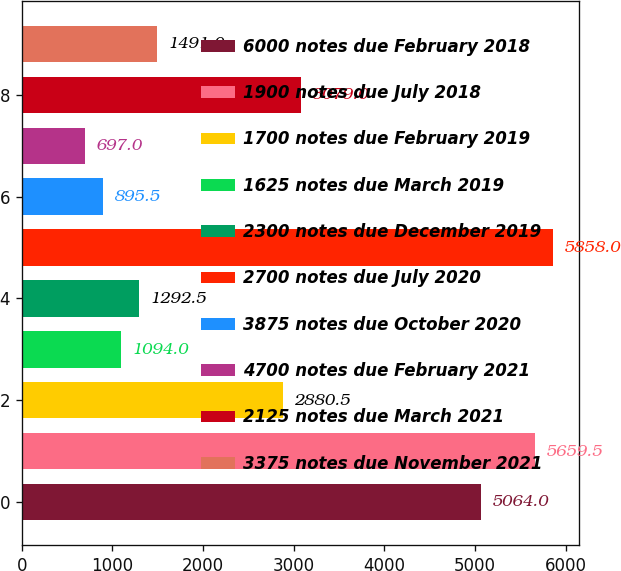<chart> <loc_0><loc_0><loc_500><loc_500><bar_chart><fcel>6000 notes due February 2018<fcel>1900 notes due July 2018<fcel>1700 notes due February 2019<fcel>1625 notes due March 2019<fcel>2300 notes due December 2019<fcel>2700 notes due July 2020<fcel>3875 notes due October 2020<fcel>4700 notes due February 2021<fcel>2125 notes due March 2021<fcel>3375 notes due November 2021<nl><fcel>5064<fcel>5659.5<fcel>2880.5<fcel>1094<fcel>1292.5<fcel>5858<fcel>895.5<fcel>697<fcel>3079<fcel>1491<nl></chart> 